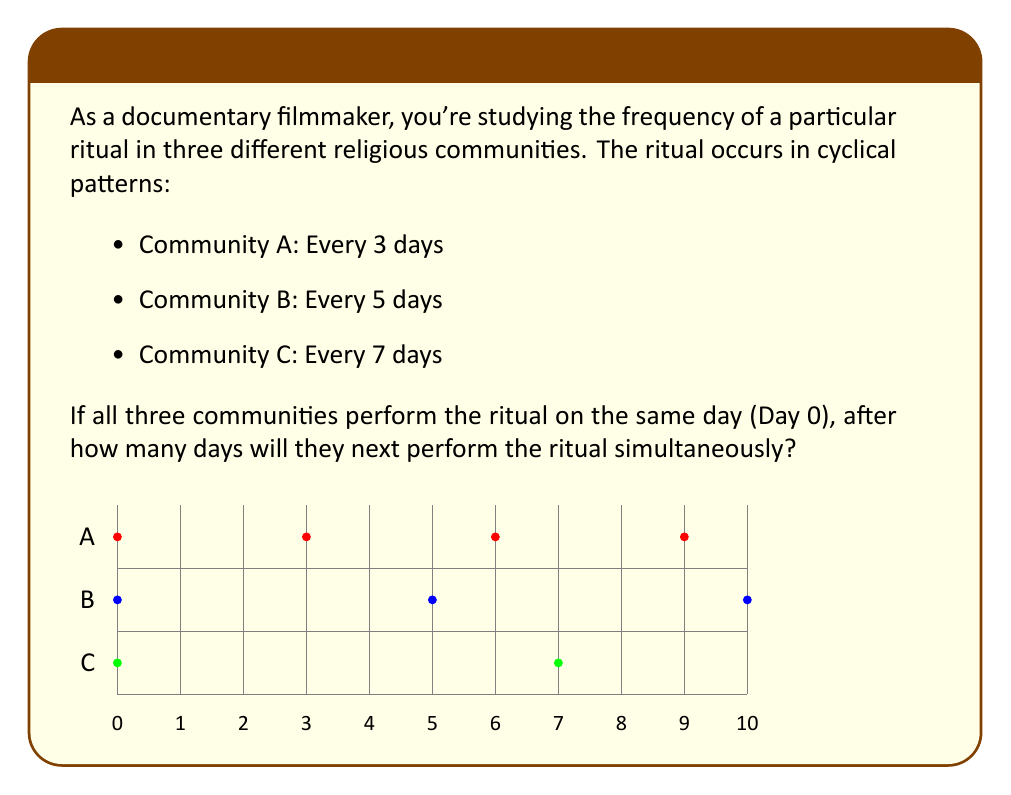Provide a solution to this math problem. To solve this problem, we need to find the least common multiple (LCM) of 3, 5, and 7. This will give us the number of days after which all three cycles align again.

Step 1: Prime factorization of the numbers
$3 = 3$
$5 = 5$
$7 = 7$

Step 2: Express the LCM
$LCM(3,5,7) = 3 \times 5 \times 7$

Step 3: Calculate the LCM
$LCM(3,5,7) = 3 \times 5 \times 7 = 105$

Therefore, the three communities will perform the ritual simultaneously every 105 days.

We can verify this:
- Community A: $105 \div 3 = 35$ (whole number)
- Community B: $105 \div 5 = 21$ (whole number)
- Community C: $105 \div 7 = 15$ (whole number)

This confirms that 105 days is divisible by all three cycle lengths, making it the first day after Day 0 when all communities perform the ritual together.
Answer: 105 days 